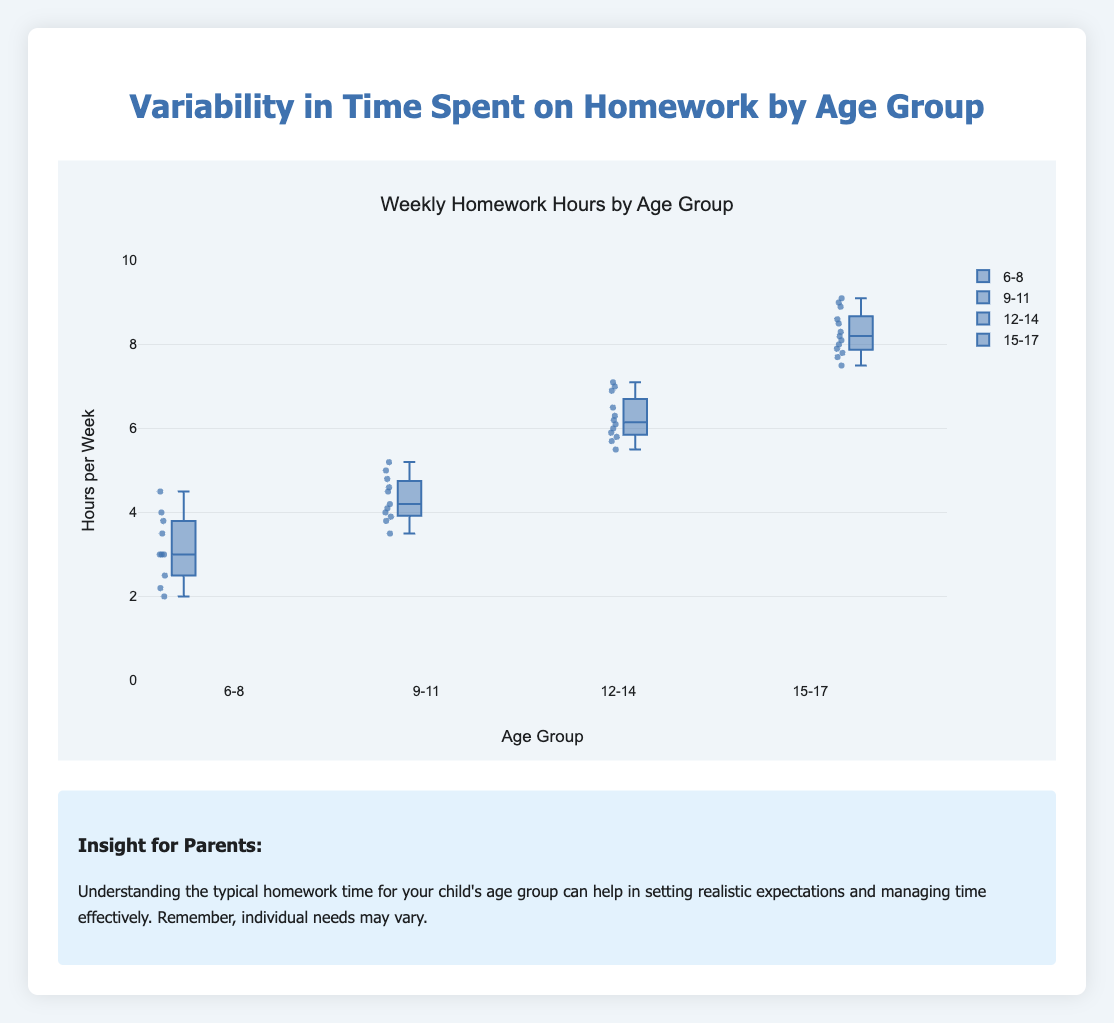What is the median time spent on homework for children aged 12-14? The box plot provides the median value as the line inside the box for each age group. For the age group 12-14, the median appears to be around 6.2 hours.
Answer: 6.2 hours Which age group has the highest median time spent on homework? By comparing the median lines (middle lines of the boxes) across all age groups, the oldest age group (15-17) has the highest median value.
Answer: 15-17 What is the range of time spent on homework for children aged 6-8? The range is determined by the distance between the lowest and highest values (whiskers) for the 6-8 age group. The minimum value is around 2 hours and the maximum is around 4.5 hours, so the range is 4.5-2 = 2.5 hours.
Answer: 2.5 hours Which age group shows the least variability in homework time? Variability is seen by the height of the box and the length of the whiskers. The 9-11 age group has the shortest box and whiskers, indicating the least variation.
Answer: 9-11 What is the interquartile range (IQR) for children aged 15-17? The IQR is the distance between the first (Q1) and third quartiles (Q3). For the 15-17 age group, Q1 is about 7.8 and Q3 is about 8.6. IQR is 8.6-7.8 = 0.8 hours.
Answer: 0.8 hours What are the outliers in the 15-17 age group? Outliers are typically marked as individual points outside the whiskers. For the 15-17 age group, values like 9 and 9.1 are visible as separate points above the whiskers.
Answer: 9 and 9.1 hours How does the average time spent on homework by children aged 6-8 differ from those aged 12-14? To find the average, sum all the values and then divide by the number of values. For ages 6-8: average = (2 + 3 + 3 + 4 + 2.5 + 3 + 4.5 + 3.5 + 2.2 + 3.8) / 10 = 3.25. For ages 12-14: average = (5.5 + 6 + 6.2 + 5.8 + 6.1 + 5.9 + 6.5 + 7 + 5.7 + 6.9 + 6.3 + 7.1) / 12 = 6.17. The difference is 6.17 - 3.25 = 2.92.
Answer: 2.92 hours Do children aged 9-11 spend more time on homework than children aged 6-8? Compare the median values of the two groups. The median for 9-11 is around 4.2 hours, whereas for 6-8 it is around 3 hours. Since 4.2 is greater than 3, children aged 9-11 spend more time on homework.
Answer: Yes, more What is the maximum time spent on homework by children aged 12-14? The maximum value is represented by the top whisker for the group aged 12-14, which appears to be around 7.1 hours.
Answer: 7.1 hours 